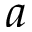<formula> <loc_0><loc_0><loc_500><loc_500>a</formula> 